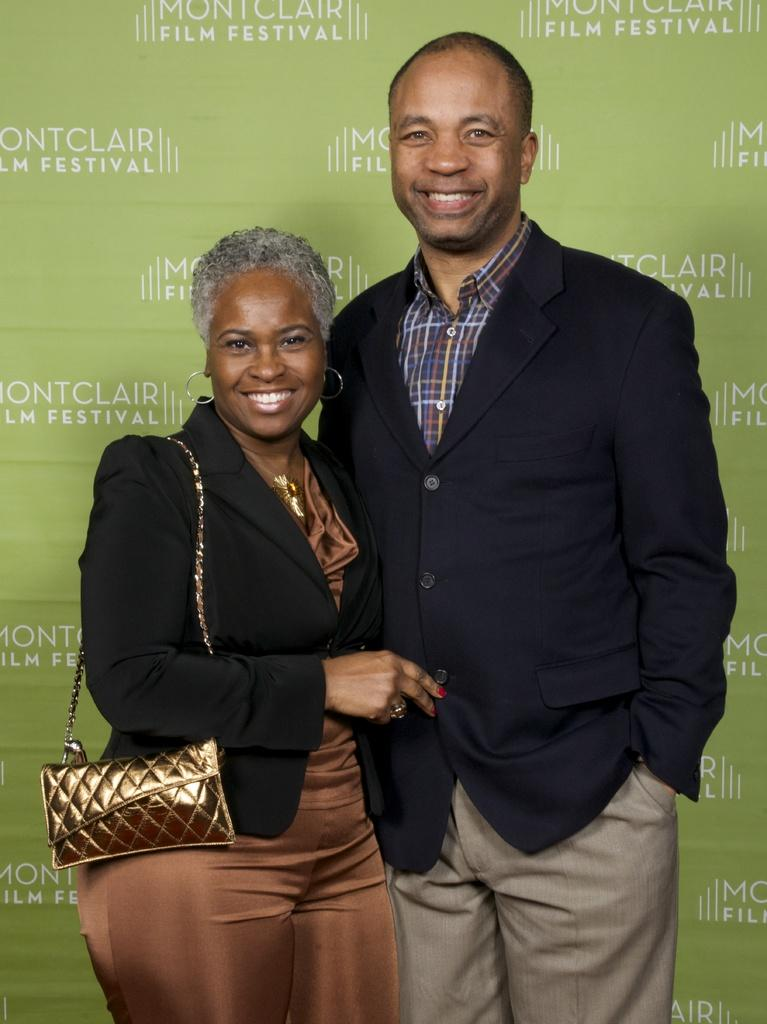Who are the people in the image? There is a woman and a man in the image. What are the people in the image doing? Both the woman and the man are standing and smiling. What can be seen in the background of the image? There is a board visible in the background of the image. How many feet are visible in the image? There is no specific mention of feet in the image, so it is not possible to determine how many are visible. 